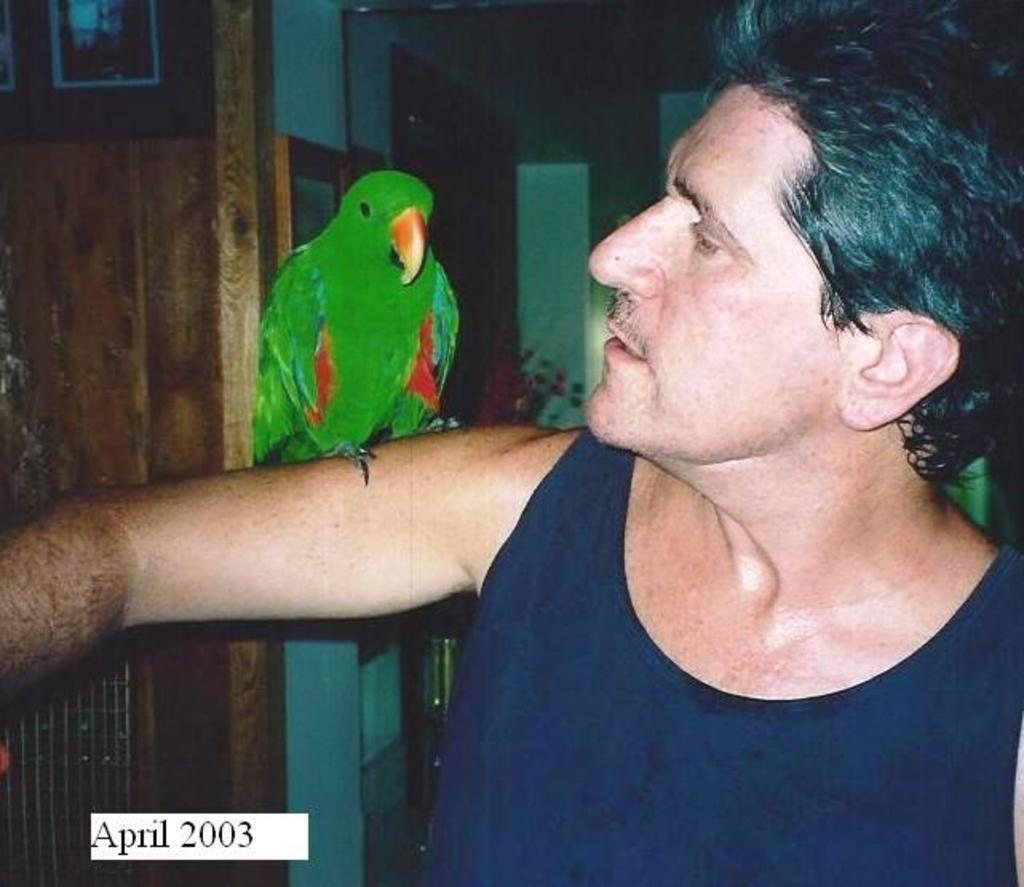What type of animal is in the image? There is a parrot in the image. Where is the parrot located in the image? The parrot is on the hand of a person. What can be seen in the background of the image? There are frames and a wall in the background of the image. What type of pets are visible in the image? There are no pets visible in the image, as the only animal present is the parrot. What is the length of the parrot's tail in the image? The length of the parrot's tail cannot be determined from the image, as the tail is not visible. 